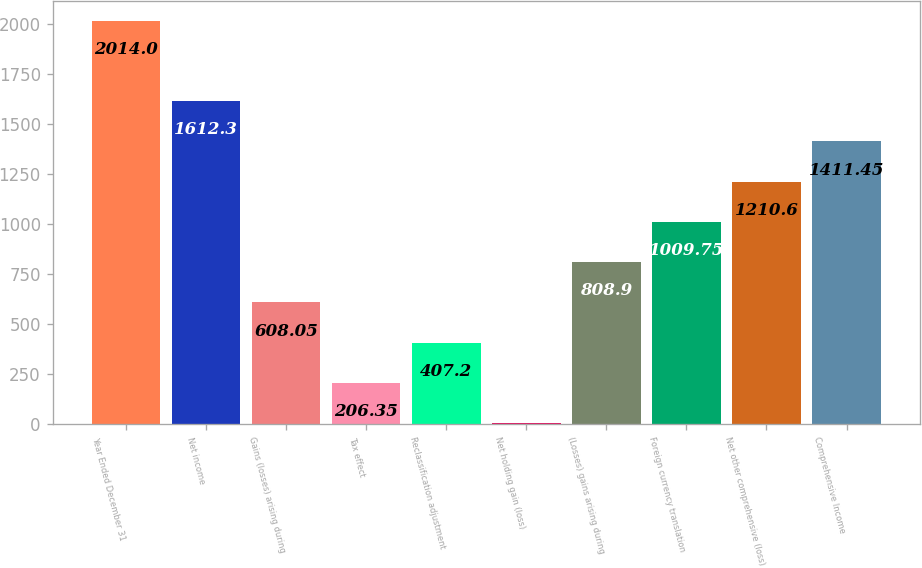<chart> <loc_0><loc_0><loc_500><loc_500><bar_chart><fcel>Year Ended December 31<fcel>Net income<fcel>Gains (losses) arising during<fcel>Tax effect<fcel>Reclassification adjustment<fcel>Net holding gain (loss)<fcel>(Losses) gains arising during<fcel>Foreign currency translation<fcel>Net other comprehensive (loss)<fcel>Comprehensive Income<nl><fcel>2014<fcel>1612.3<fcel>608.05<fcel>206.35<fcel>407.2<fcel>5.5<fcel>808.9<fcel>1009.75<fcel>1210.6<fcel>1411.45<nl></chart> 